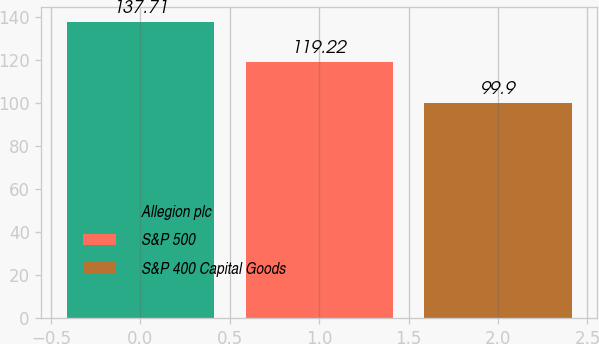Convert chart to OTSL. <chart><loc_0><loc_0><loc_500><loc_500><bar_chart><fcel>Allegion plc<fcel>S&P 500<fcel>S&P 400 Capital Goods<nl><fcel>137.71<fcel>119.22<fcel>99.9<nl></chart> 